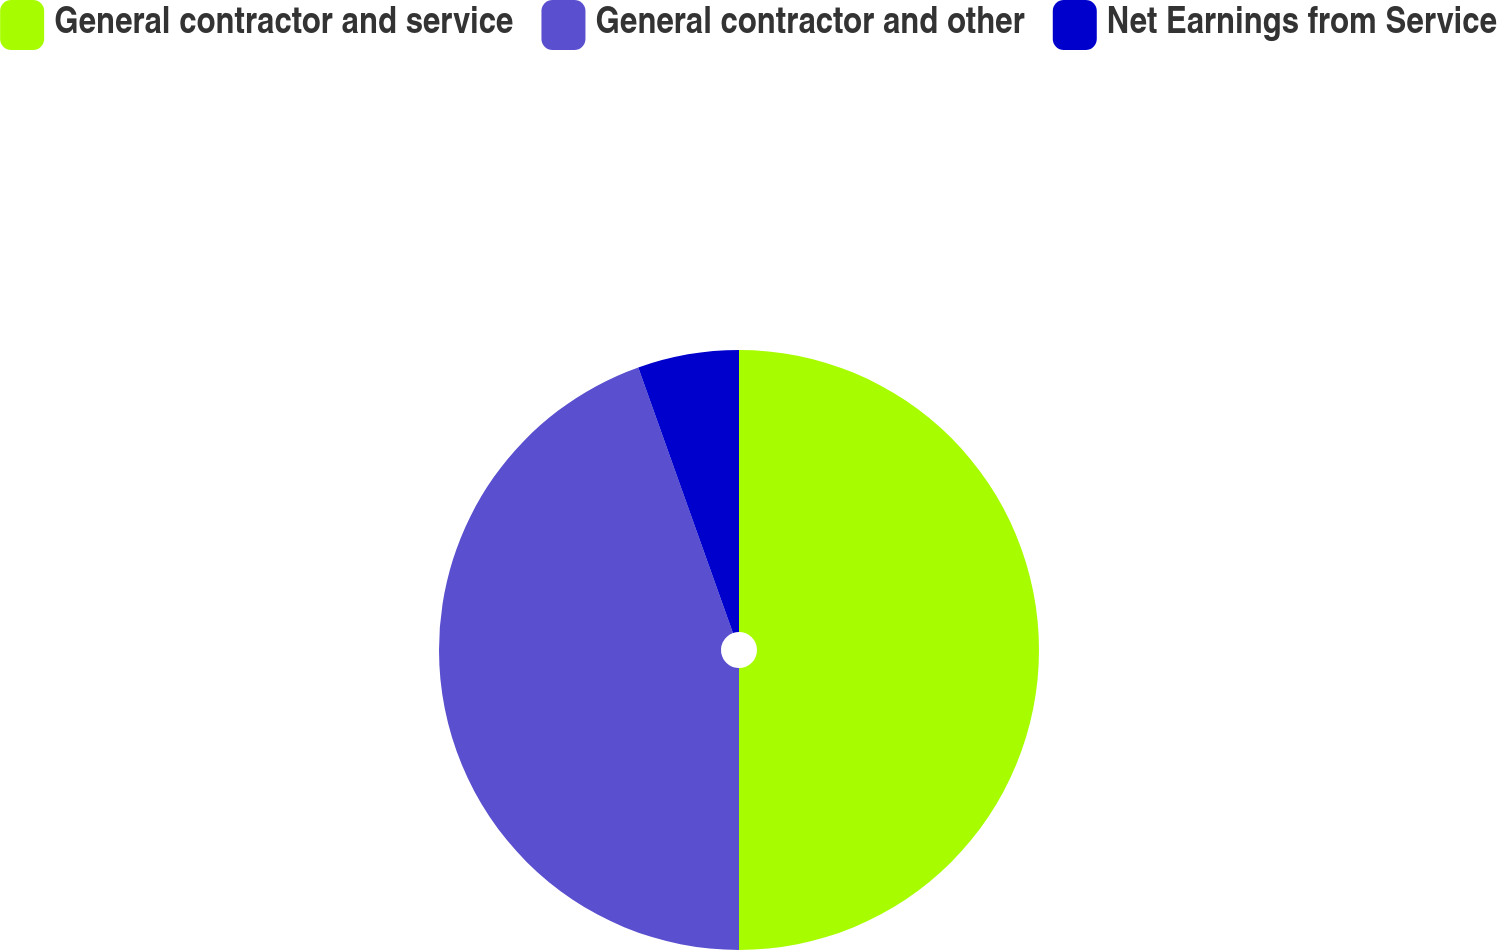<chart> <loc_0><loc_0><loc_500><loc_500><pie_chart><fcel>General contractor and service<fcel>General contractor and other<fcel>Net Earnings from Service<nl><fcel>50.0%<fcel>44.55%<fcel>5.45%<nl></chart> 